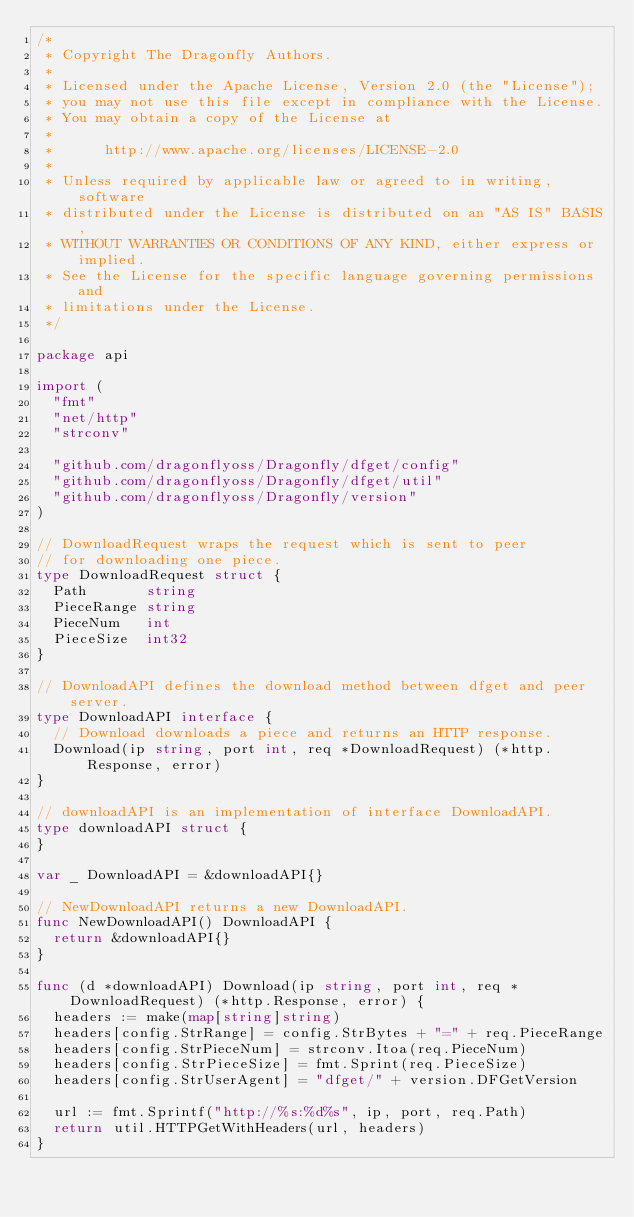<code> <loc_0><loc_0><loc_500><loc_500><_Go_>/*
 * Copyright The Dragonfly Authors.
 *
 * Licensed under the Apache License, Version 2.0 (the "License");
 * you may not use this file except in compliance with the License.
 * You may obtain a copy of the License at
 *
 *      http://www.apache.org/licenses/LICENSE-2.0
 *
 * Unless required by applicable law or agreed to in writing, software
 * distributed under the License is distributed on an "AS IS" BASIS,
 * WITHOUT WARRANTIES OR CONDITIONS OF ANY KIND, either express or implied.
 * See the License for the specific language governing permissions and
 * limitations under the License.
 */

package api

import (
	"fmt"
	"net/http"
	"strconv"

	"github.com/dragonflyoss/Dragonfly/dfget/config"
	"github.com/dragonflyoss/Dragonfly/dfget/util"
	"github.com/dragonflyoss/Dragonfly/version"
)

// DownloadRequest wraps the request which is sent to peer
// for downloading one piece.
type DownloadRequest struct {
	Path       string
	PieceRange string
	PieceNum   int
	PieceSize  int32
}

// DownloadAPI defines the download method between dfget and peer server.
type DownloadAPI interface {
	// Download downloads a piece and returns an HTTP response.
	Download(ip string, port int, req *DownloadRequest) (*http.Response, error)
}

// downloadAPI is an implementation of interface DownloadAPI.
type downloadAPI struct {
}

var _ DownloadAPI = &downloadAPI{}

// NewDownloadAPI returns a new DownloadAPI.
func NewDownloadAPI() DownloadAPI {
	return &downloadAPI{}
}

func (d *downloadAPI) Download(ip string, port int, req *DownloadRequest) (*http.Response, error) {
	headers := make(map[string]string)
	headers[config.StrRange] = config.StrBytes + "=" + req.PieceRange
	headers[config.StrPieceNum] = strconv.Itoa(req.PieceNum)
	headers[config.StrPieceSize] = fmt.Sprint(req.PieceSize)
	headers[config.StrUserAgent] = "dfget/" + version.DFGetVersion

	url := fmt.Sprintf("http://%s:%d%s", ip, port, req.Path)
	return util.HTTPGetWithHeaders(url, headers)
}
</code> 